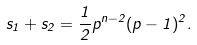Convert formula to latex. <formula><loc_0><loc_0><loc_500><loc_500>s _ { 1 } + s _ { 2 } = \frac { 1 } { 2 } p ^ { n - 2 } ( p - 1 ) ^ { 2 } .</formula> 